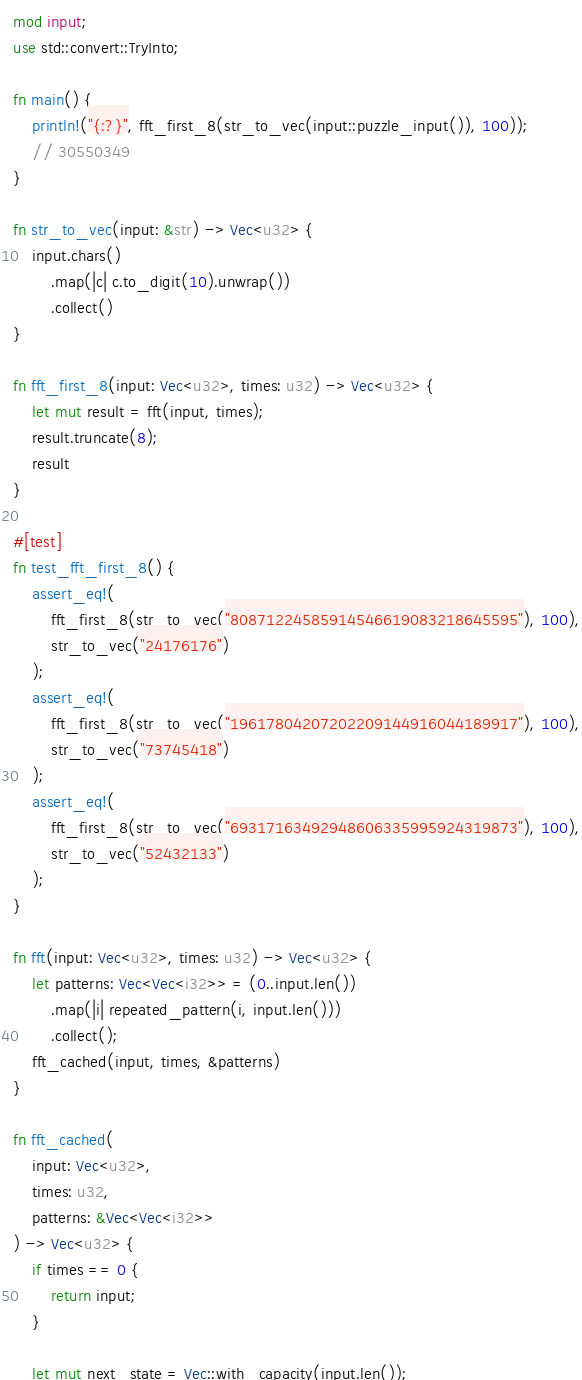<code> <loc_0><loc_0><loc_500><loc_500><_Rust_>mod input;
use std::convert::TryInto;

fn main() {
	println!("{:?}", fft_first_8(str_to_vec(input::puzzle_input()), 100));
	// 30550349
}

fn str_to_vec(input: &str) -> Vec<u32> {
	input.chars()
		.map(|c| c.to_digit(10).unwrap())
		.collect()
}

fn fft_first_8(input: Vec<u32>, times: u32) -> Vec<u32> {
	let mut result = fft(input, times);
	result.truncate(8);
	result
}

#[test]
fn test_fft_first_8() {
	assert_eq!(
		fft_first_8(str_to_vec("80871224585914546619083218645595"), 100),
		str_to_vec("24176176")
	);
	assert_eq!(
		fft_first_8(str_to_vec("19617804207202209144916044189917"), 100),
		str_to_vec("73745418")
	);
	assert_eq!(
		fft_first_8(str_to_vec("69317163492948606335995924319873"), 100),
		str_to_vec("52432133")
	);
}

fn fft(input: Vec<u32>, times: u32) -> Vec<u32> {
	let patterns: Vec<Vec<i32>> = (0..input.len())
		.map(|i| repeated_pattern(i, input.len()))
		.collect();
	fft_cached(input, times, &patterns)
}

fn fft_cached(
	input: Vec<u32>,
	times: u32,
	patterns: &Vec<Vec<i32>>
) -> Vec<u32> {
	if times == 0 {
		return input;
	}

	let mut next_state = Vec::with_capacity(input.len());
</code> 